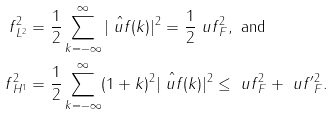Convert formula to latex. <formula><loc_0><loc_0><loc_500><loc_500>\| f \| _ { L ^ { 2 } } ^ { 2 } & = \frac { 1 } { 2 } \sum _ { k = - \infty } ^ { \infty } | \hat { \ u f } ( k ) | ^ { 2 } = \frac { 1 } { 2 } \| \ u f \| _ { F } ^ { 2 } , \text { and } \\ \| f \| _ { H ^ { 1 } } ^ { 2 } & = \frac { 1 } { 2 } \sum _ { k = - \infty } ^ { \infty } ( 1 + k ) ^ { 2 } | \hat { \ u f } ( k ) | ^ { 2 } \leq \| \ u f \| _ { F } ^ { 2 } + \| \ u f ^ { \prime } \| _ { F } ^ { 2 } .</formula> 